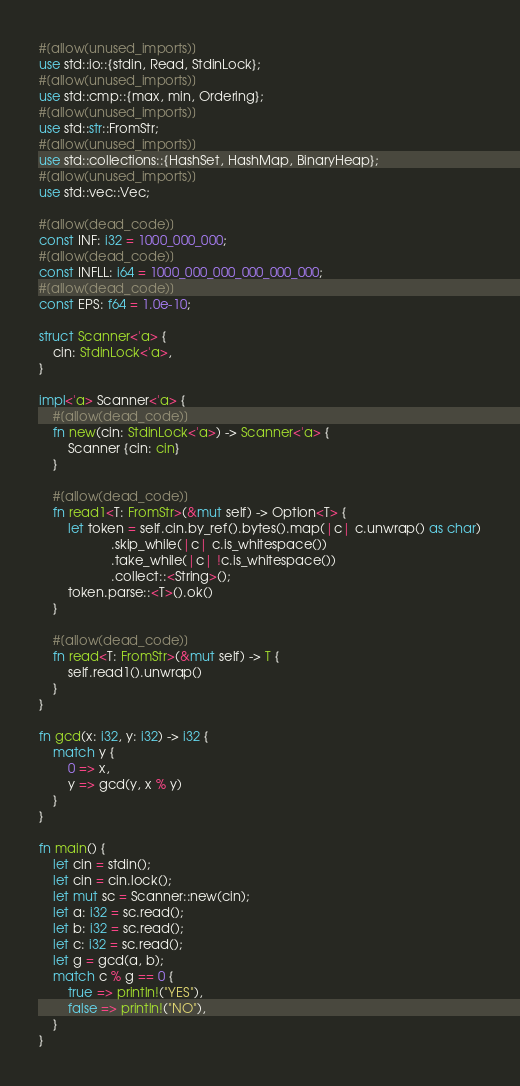Convert code to text. <code><loc_0><loc_0><loc_500><loc_500><_Rust_>#[allow(unused_imports)]
use std::io::{stdin, Read, StdinLock};
#[allow(unused_imports)]
use std::cmp::{max, min, Ordering};
#[allow(unused_imports)]
use std::str::FromStr;
#[allow(unused_imports)]
use std::collections::{HashSet, HashMap, BinaryHeap};
#[allow(unused_imports)]
use std::vec::Vec;

#[allow(dead_code)]
const INF: i32 = 1000_000_000;
#[allow(dead_code)]
const INFLL: i64 = 1000_000_000_000_000_000;
#[allow(dead_code)]
const EPS: f64 = 1.0e-10;

struct Scanner<'a> {
    cin: StdinLock<'a>,
}

impl<'a> Scanner<'a> {
    #[allow(dead_code)]
    fn new(cin: StdinLock<'a>) -> Scanner<'a> {
        Scanner {cin: cin}
    }

    #[allow(dead_code)]
    fn read1<T: FromStr>(&mut self) -> Option<T> {
        let token = self.cin.by_ref().bytes().map(|c| c.unwrap() as char)
                    .skip_while(|c| c.is_whitespace())
                    .take_while(|c| !c.is_whitespace())
                    .collect::<String>();
        token.parse::<T>().ok()
    }

    #[allow(dead_code)]
    fn read<T: FromStr>(&mut self) -> T {
        self.read1().unwrap()
    }
}

fn gcd(x: i32, y: i32) -> i32 {
    match y {
        0 => x,
        y => gcd(y, x % y)
    }
}

fn main() {
    let cin = stdin();
    let cin = cin.lock();
    let mut sc = Scanner::new(cin);
    let a: i32 = sc.read();
    let b: i32 = sc.read();
    let c: i32 = sc.read();
    let g = gcd(a, b);
    match c % g == 0 {
        true => println!("YES"),
        false => println!("NO"),
    }
}</code> 